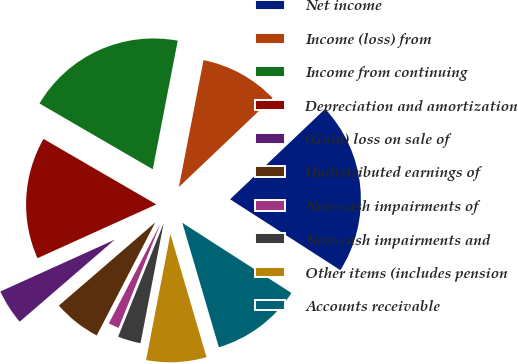Convert chart to OTSL. <chart><loc_0><loc_0><loc_500><loc_500><pie_chart><fcel>Net income<fcel>Income (loss) from<fcel>Income from continuing<fcel>Depreciation and amortization<fcel>(Gain) loss on sale of<fcel>Undistributed earnings of<fcel>Non-cash impairments of<fcel>Non-cash impairments and<fcel>Other items (includes pension<fcel>Accounts receivable<nl><fcel>21.19%<fcel>9.85%<fcel>19.68%<fcel>15.14%<fcel>4.56%<fcel>6.07%<fcel>1.53%<fcel>3.04%<fcel>7.58%<fcel>11.36%<nl></chart> 